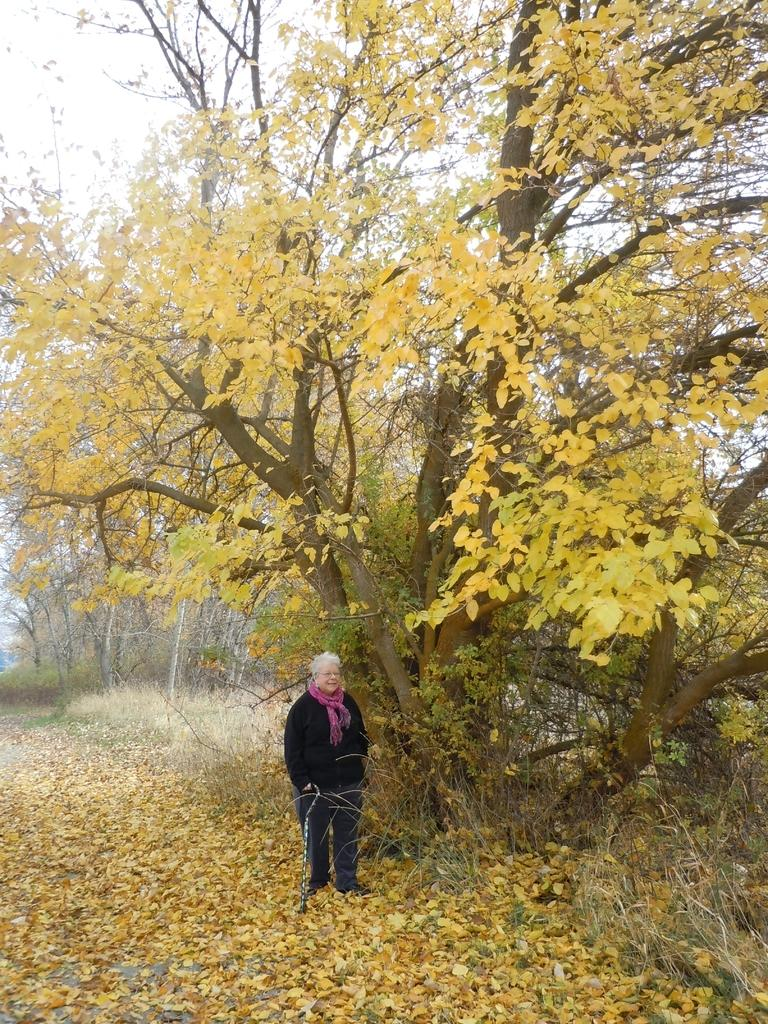Who or what is present in the image? There is a person in the image. What is the person wearing? The person is wearing clothes. What is in the background of the image? The person is standing in front of a tree. What is on the ground in the image? There are dry leaves on the ground. What activity is the person performing to stop the tree from falling in the image? There is no indication in the image that the person is trying to stop the tree from falling or performing any activity related to the tree. 